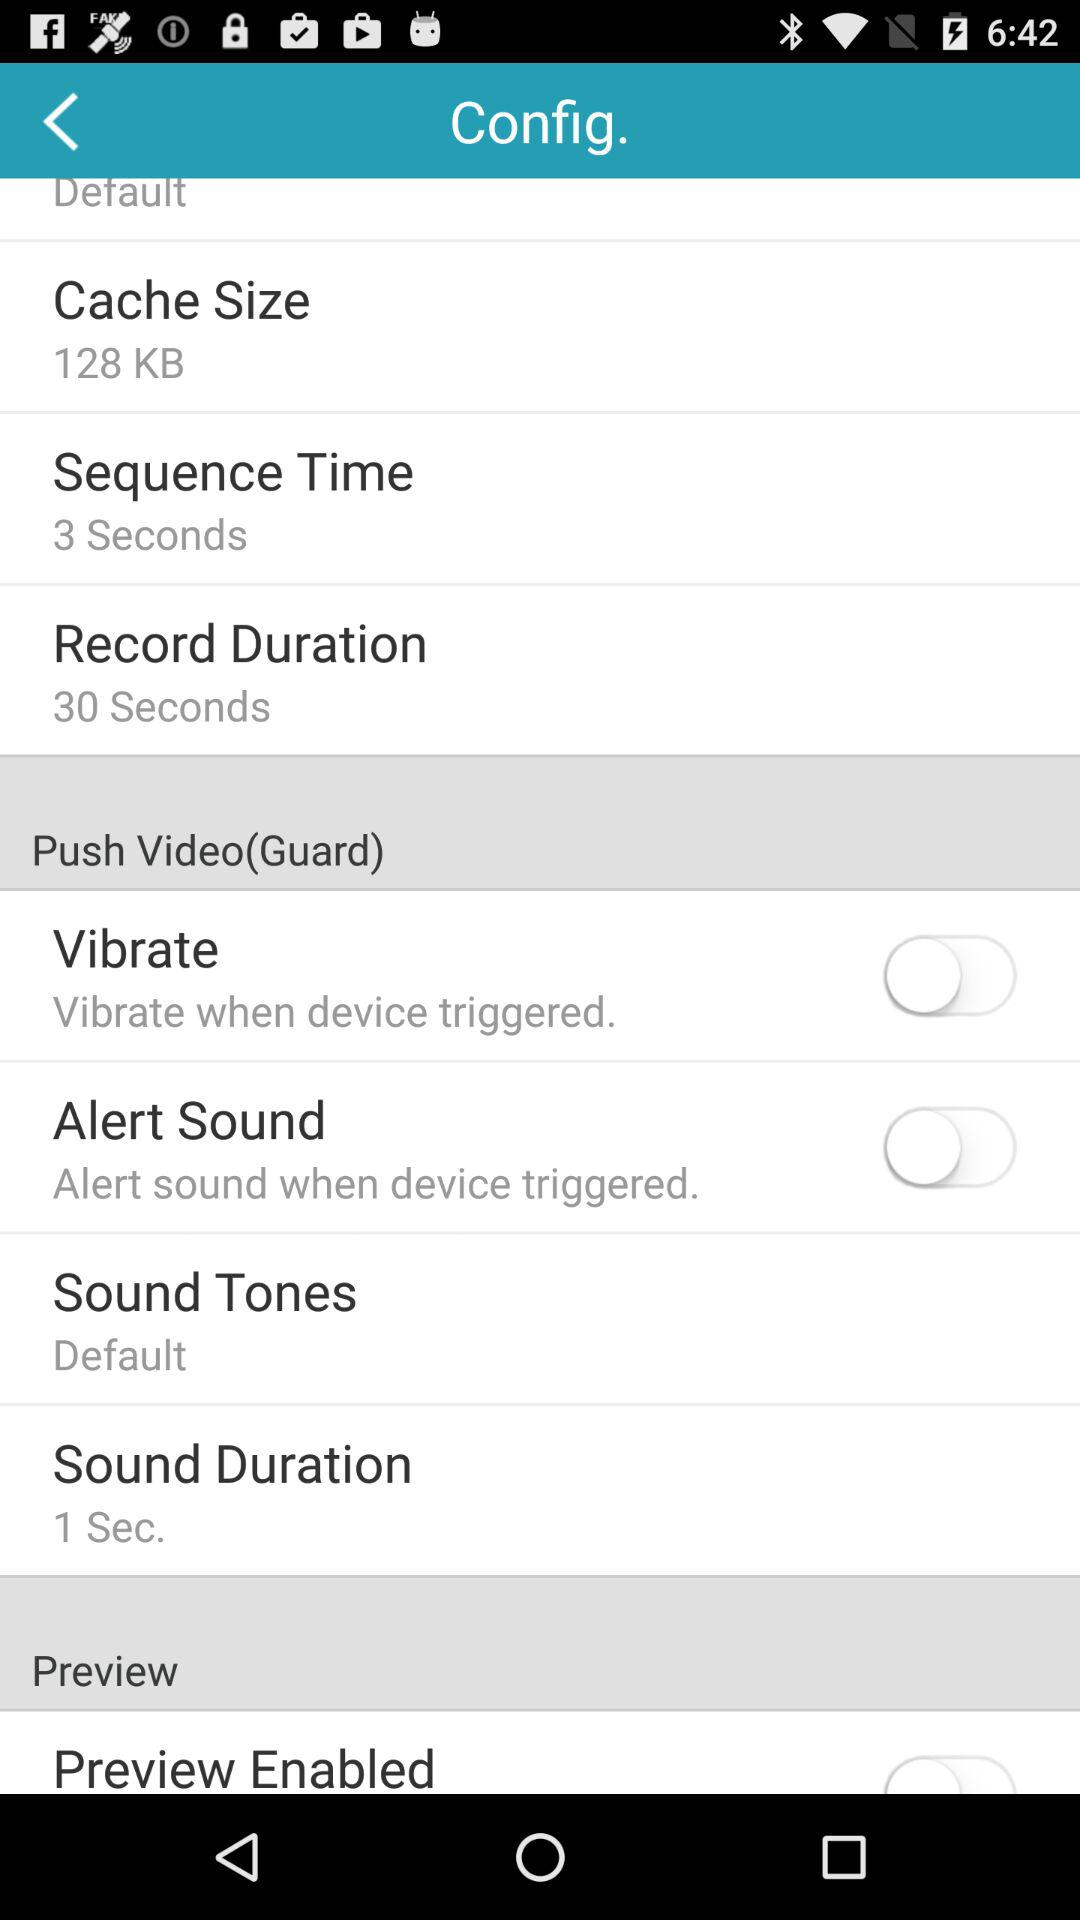What is the name of the application?
When the provided information is insufficient, respond with <no answer>. <no answer> 